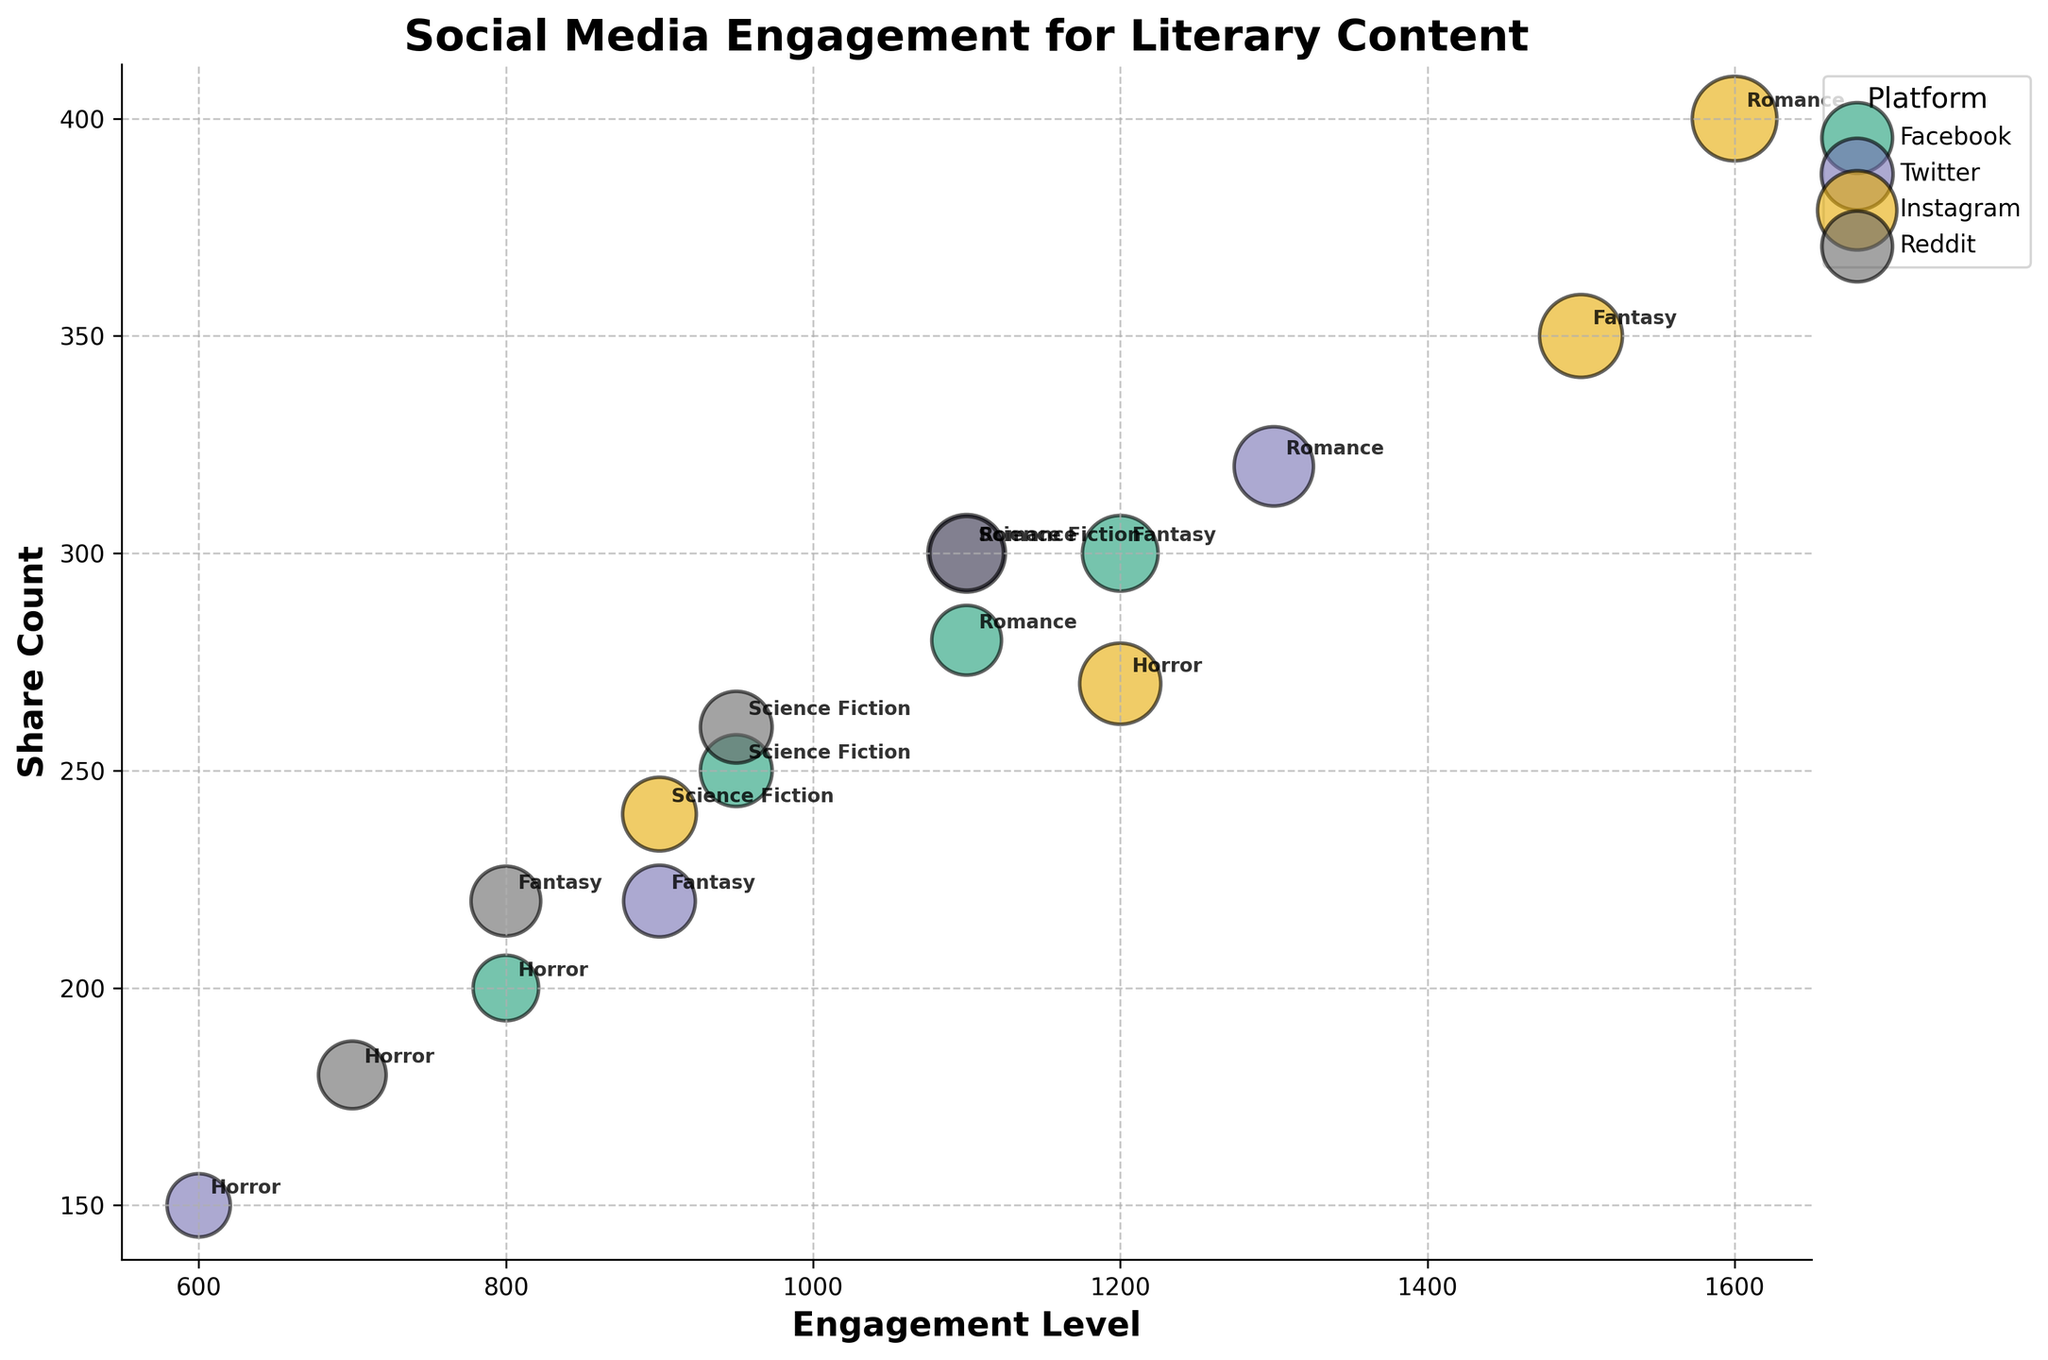What's the title of the figure? The title is usually displayed at the top of the graph. By looking at the figure, the title can be read directly as it is clear and prominently positioned.
Answer: Social Media Engagement for Literary Content What are the axes labeled? Axes labels are found along the horizontal and vertical lines of the graph. The x-axis label is positioned along the bottom, and the y-axis label is along the left side of the graph.
Answer: Engagement Level (x-axis) and Share Count (y-axis) Which platform has the largest bubble for Romance content? By looking at the 'Romance' label next to the bubbles and comparing their sizes, the largest bubble corresponds to the platform with the highest 'Bubble_Size' attribute.
Answer: Instagram What is the engagement level and share count for the Horror content on Twitter? Locate the bubble labeled 'Horror' under the scatter points for Twitter. By checking its position along the x-axis (Engagement Level) and y-axis (Share Count), the values can be read directly.
Answer: Engagement Level: 600, Share Count: 150 Which type of literary content has the highest engagement level on Reddit? By examining the bubbles under Reddit data points and comparing the x-axis positions, identify the bubble furthest to the right.
Answer: Science Fiction What is the difference in engagement levels between Romance and Fantasy content on Facebook? Identify the Romance and Fantasy bubbles within the Facebook section and note their x-axis positions (Engagement Levels). Subtract the engagement level of Fantasy from that of Romance.
Answer: 1100 - 1200 = -100, so -100 How does the share count for Science Fiction content on Twitter compare to that on Instagram? Locate the Science Fiction bubbles under Twitter and Instagram, then compare their y-axis positions (Share Counts).
Answer: Twitter: 300, Instagram: 240. Twitter has a higher share count Which platform has the lowest engagement level for Horror content? Identify all the Horror bubbles and compare their x-axis positions. The platform associated with the bubble furthest to the left has the lowest engagement level.
Answer: Twitter If you average the engagement levels of Fantasy content across all platforms, what do you get? Identify the engagement levels for Fantasy content on Facebook, Twitter, Instagram, and Reddit. Sum these levels and divide by the number of platforms.
Answer: (1200 + 900 + 1500 + 800) / 4 = 1100 What can be inferred about the relationship between bubble size and engagement level for Romance content? Compare the bubble sizes and engagement levels of Romance content across all platforms to check for any patterns or trends.
Answer: Larger bubbles, which indicate higher comment counts, tend to align with higher engagement levels. Instagram has both the highest engagement level and largest bubble for Romance content 